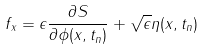Convert formula to latex. <formula><loc_0><loc_0><loc_500><loc_500>f _ { x } = \epsilon \frac { \partial S } { \partial \phi ( x , t _ { n } ) } + \sqrt { \epsilon } \eta ( x , t _ { n } )</formula> 